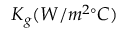<formula> <loc_0><loc_0><loc_500><loc_500>K _ { g } ( W / m ^ { 2 \circ } C )</formula> 